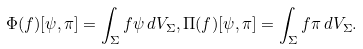<formula> <loc_0><loc_0><loc_500><loc_500>\Phi ( f ) [ \psi , \pi ] = \int _ { \Sigma } f \psi \, d V _ { \Sigma } , \Pi ( f ) [ \psi , \pi ] = \int _ { \Sigma } f \pi \, d V _ { \Sigma } .</formula> 